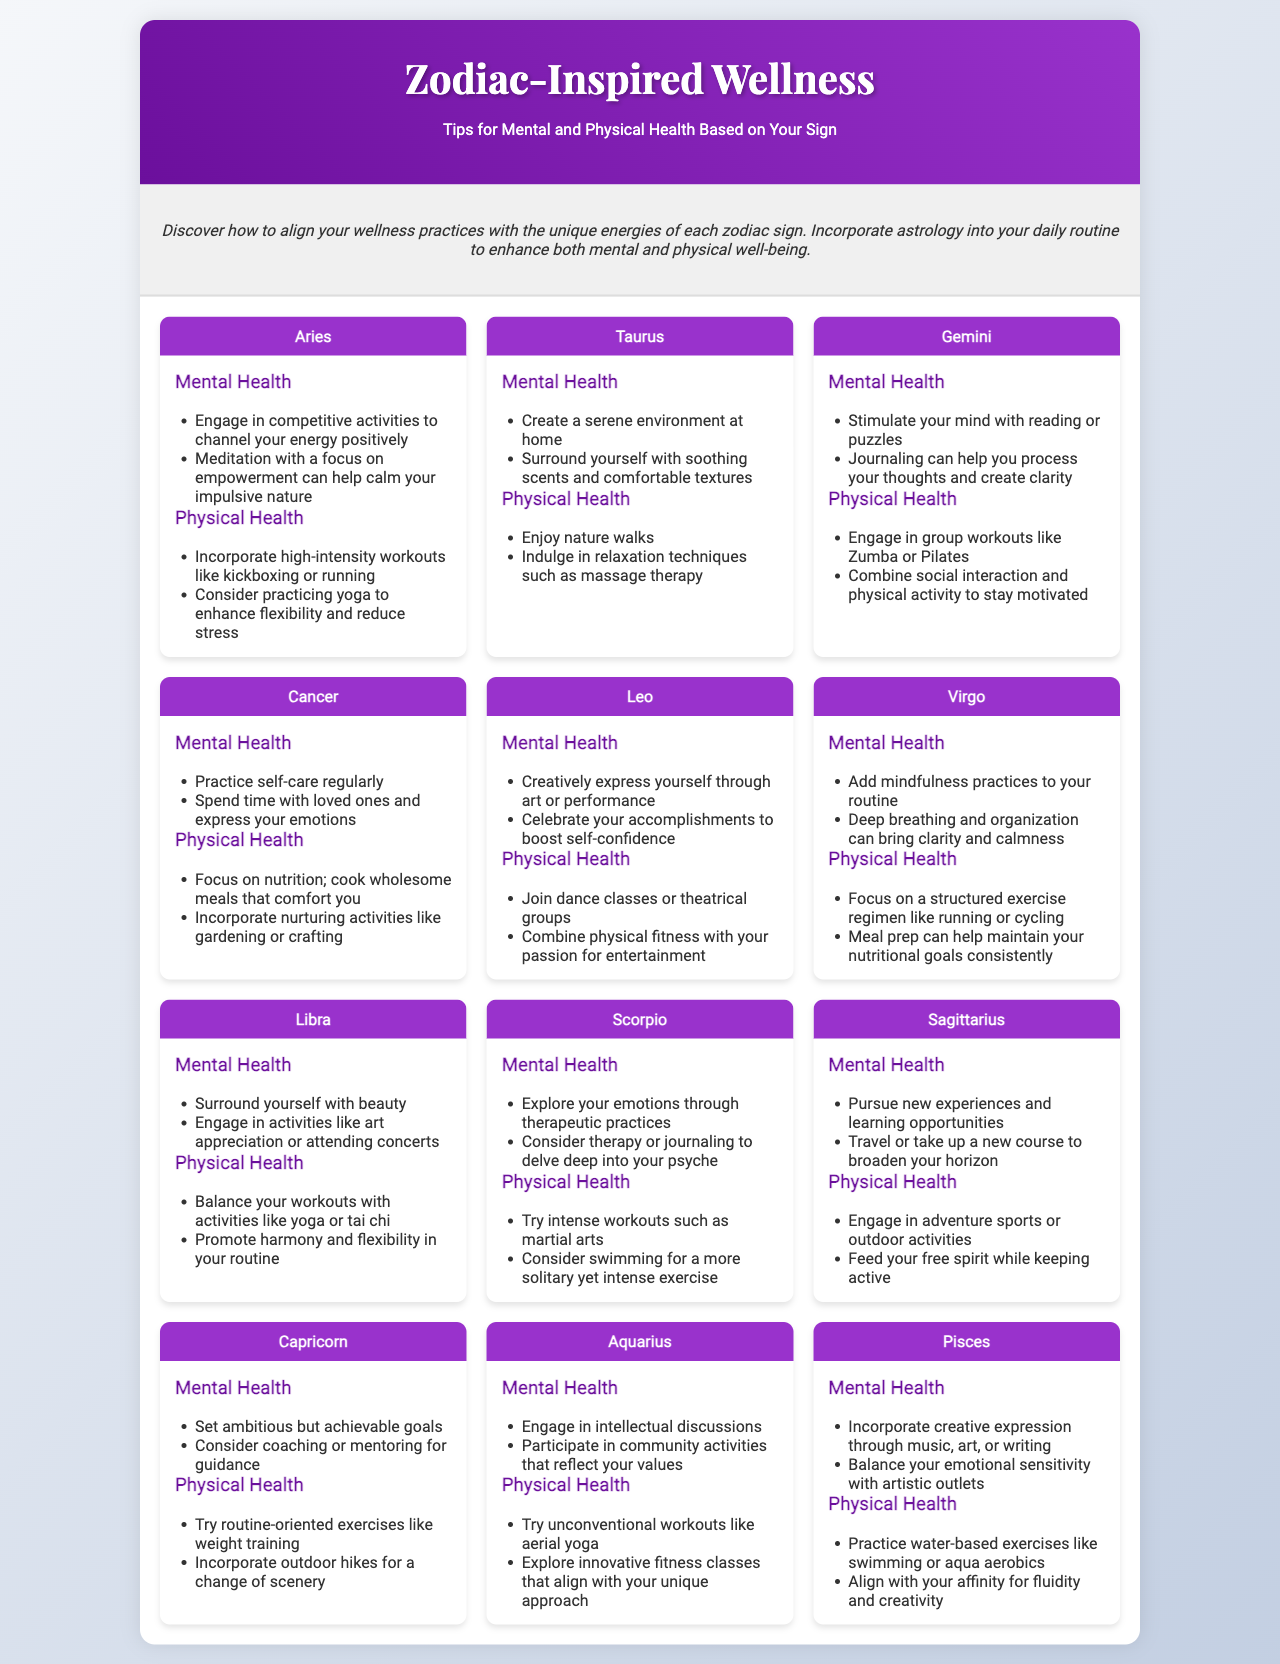What is the title of the brochure? The title of the brochure is presented in the header section.
Answer: Zodiac-Inspired Wellness How many zodiac signs are included in the brochure? The brochure contains a card for each zodiac sign, totaling twelve signs.
Answer: 12 What mental health tip is suggested for Aries? The tip for Aries is found in the Aries card under mental health.
Answer: Engage in competitive activities Which zodiac sign suggests creating a serene environment for mental health? The serene environment suggestion is specifically related to one zodiac sign.
Answer: Taurus What physical activity does Sagittarius recommend? The recommendation for Sagittarius can be found under physical health tips.
Answer: Adventure sports Which zodiac sign advises engaging in intellectual discussions? This information is located in the Aquarius card under mental health.
Answer: Aquarius What type of workouts does Scorpio suggest? The Scorpio card contains a suggestion for physical activity.
Answer: Martial arts How can Pisces express their emotional sensitivity? This question focuses on a specific mental health strategy from Pisces.
Answer: Creative expression Which zodiac sign is associated with high-intensity workouts? High-intensity workouts are mentioned in the physical health section of a specific sign.
Answer: Aries 